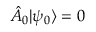<formula> <loc_0><loc_0><loc_500><loc_500>\hat { A } _ { 0 } | \psi _ { 0 } \rangle = 0</formula> 